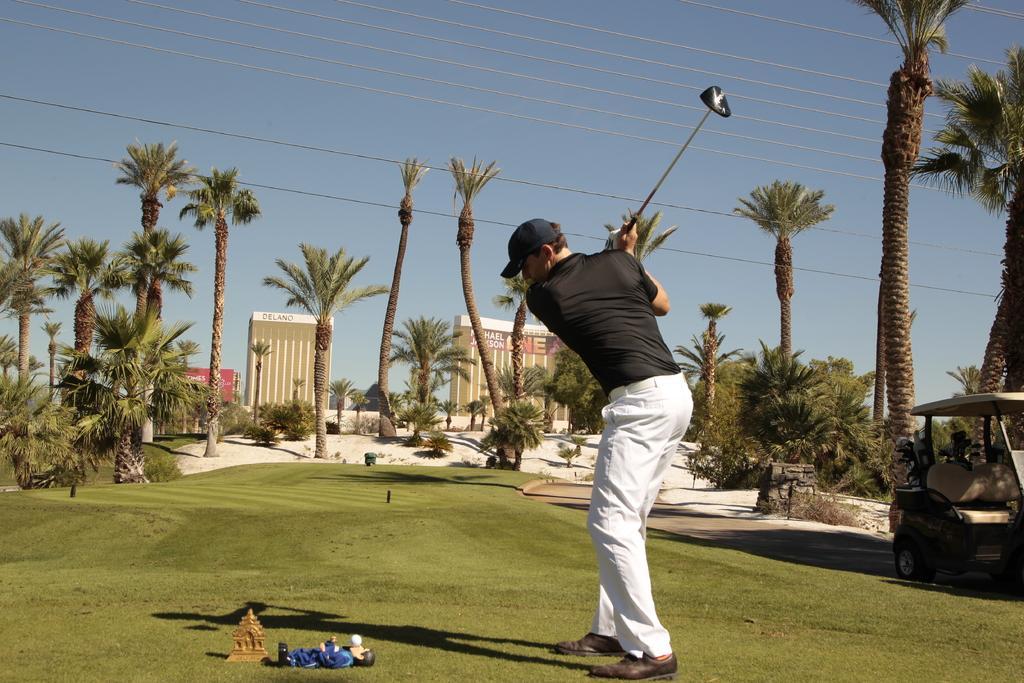Can you describe this image briefly? In this image I see a man who is wearing black t-shirt and white pants and black cap on his head and I see that he is holding a golf bat in his hands and I see few things over here and I see the white ball and I see the grass. In the background I see number of trees, wires, buildings and I see a vehicle over here and I see the clear sky. 